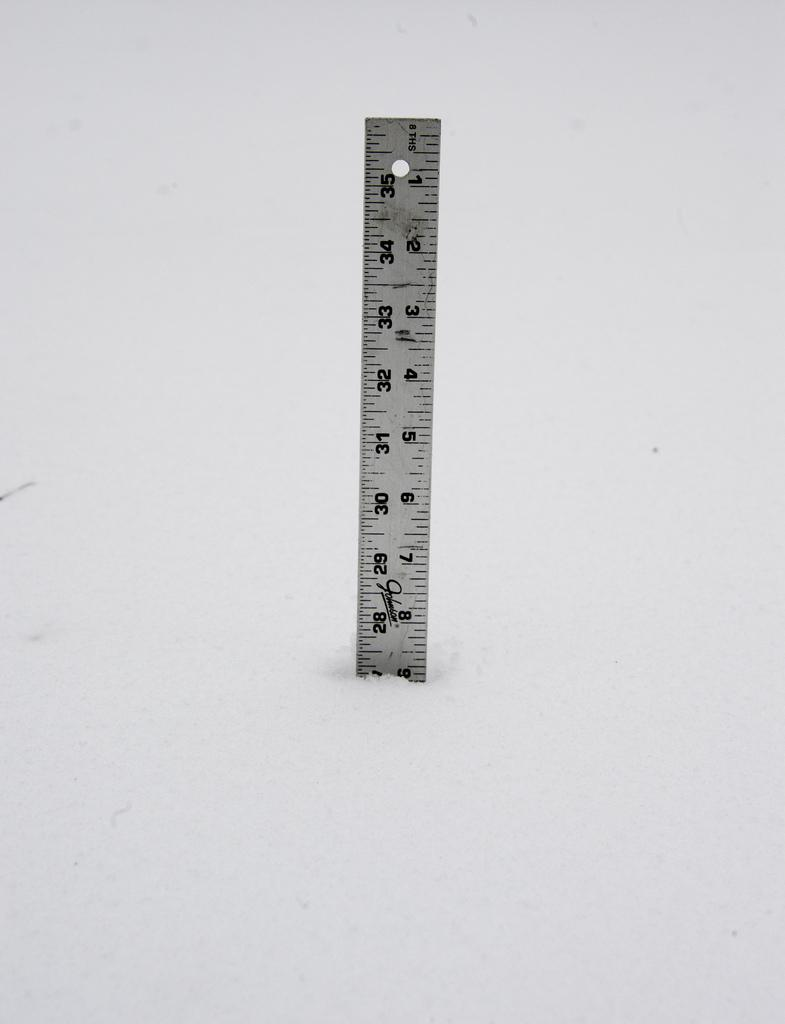<image>
Share a concise interpretation of the image provided. A silver metal ruler that is broken off at the 9 inch mark. 